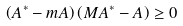<formula> <loc_0><loc_0><loc_500><loc_500>\left ( A ^ { \ast } - m A \right ) \left ( M A ^ { \ast } - A \right ) \geq 0</formula> 